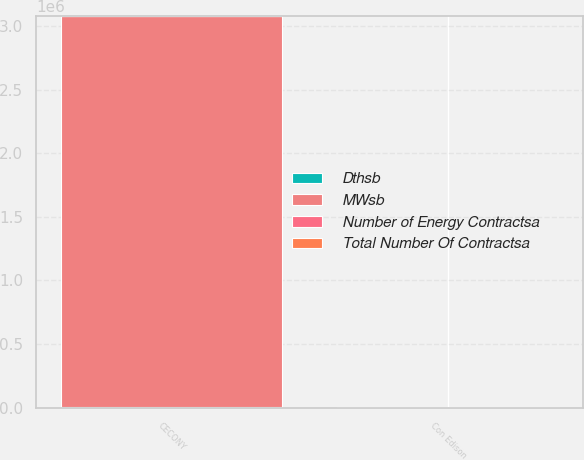<chart> <loc_0><loc_0><loc_500><loc_500><stacked_bar_chart><ecel><fcel>Con Edison<fcel>CECONY<nl><fcel>Number of Energy Contractsa<fcel>501<fcel>75<nl><fcel>MWsb<fcel>501<fcel>3.07585e+06<nl><fcel>Total Number Of Contractsa<fcel>61<fcel>4<nl><fcel>Dthsb<fcel>6376<fcel>1200<nl></chart> 